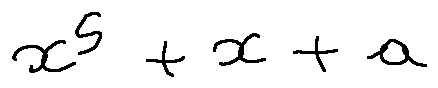Convert formula to latex. <formula><loc_0><loc_0><loc_500><loc_500>x ^ { 5 } + x + a</formula> 